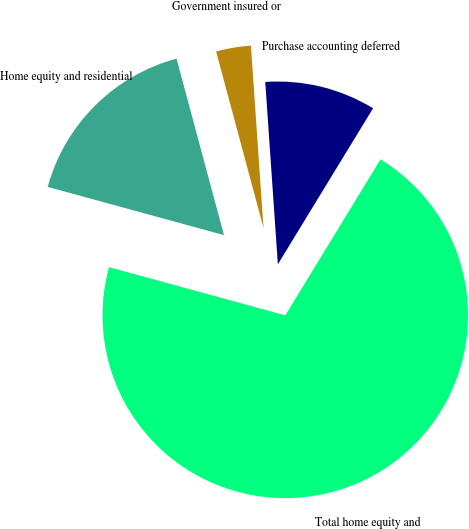<chart> <loc_0><loc_0><loc_500><loc_500><pie_chart><fcel>Home equity and residential<fcel>Government insured or<fcel>Purchase accounting deferred<fcel>Total home equity and<nl><fcel>16.57%<fcel>3.08%<fcel>9.82%<fcel>70.53%<nl></chart> 